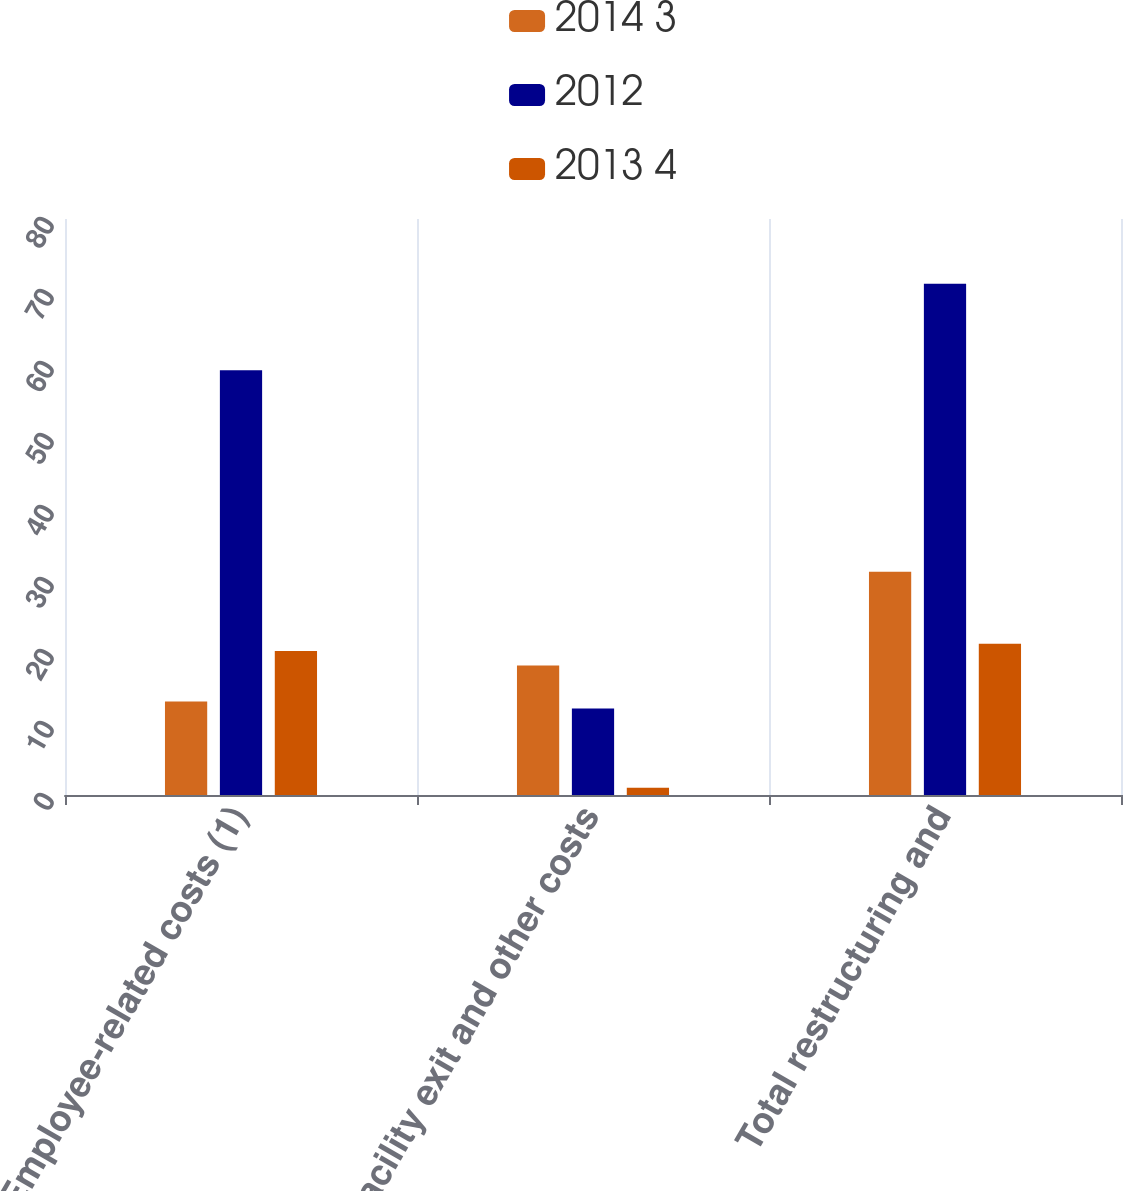<chart> <loc_0><loc_0><loc_500><loc_500><stacked_bar_chart><ecel><fcel>Employee-related costs (1)<fcel>Facility exit and other costs<fcel>Total restructuring and<nl><fcel>2014 3<fcel>13<fcel>18<fcel>31<nl><fcel>2012<fcel>59<fcel>12<fcel>71<nl><fcel>2013 4<fcel>20<fcel>1<fcel>21<nl></chart> 